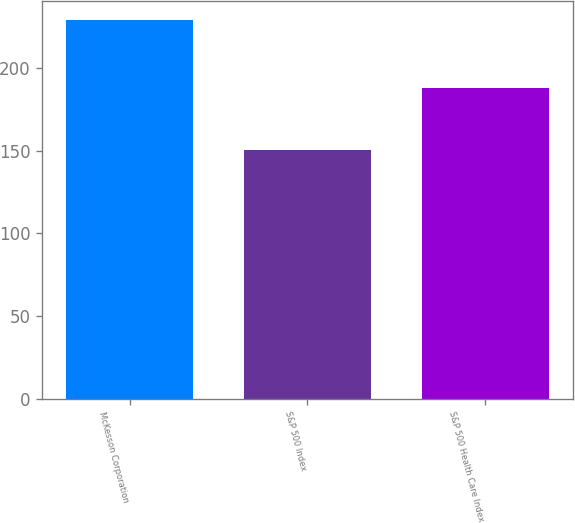Convert chart. <chart><loc_0><loc_0><loc_500><loc_500><bar_chart><fcel>McKesson Corporation<fcel>S&P 500 Index<fcel>S&P 500 Health Care Index<nl><fcel>229.03<fcel>150.73<fcel>188.21<nl></chart> 